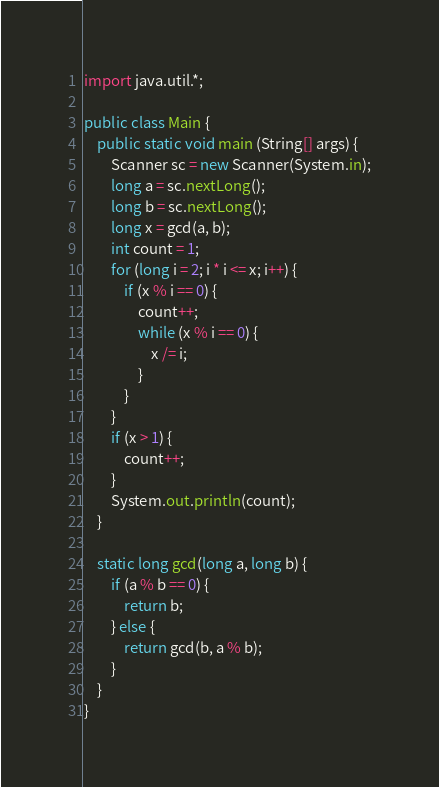Convert code to text. <code><loc_0><loc_0><loc_500><loc_500><_Java_>import java.util.*;

public class Main {
	public static void main (String[] args) {
		Scanner sc = new Scanner(System.in);
		long a = sc.nextLong();
		long b = sc.nextLong();
		long x = gcd(a, b);
		int count = 1;
		for (long i = 2; i * i <= x; i++) {
			if (x % i == 0) {
				count++;
				while (x % i == 0) {
					x /= i;
				}
			}
		}
		if (x > 1) {
			count++;
		}
		System.out.println(count);
	}
	
	static long gcd(long a, long b) {
		if (a % b == 0) {
			return b;
		} else {
			return gcd(b, a % b);
		}
	}
}
</code> 